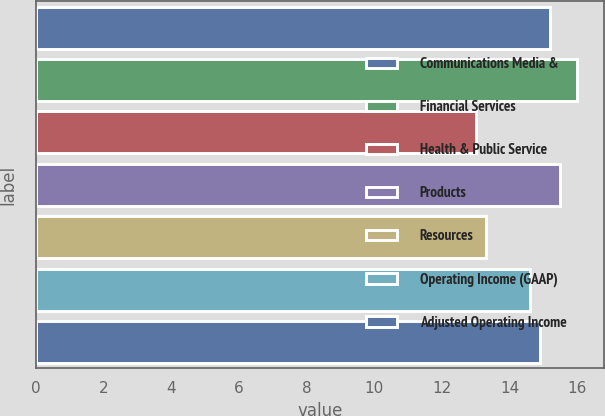<chart> <loc_0><loc_0><loc_500><loc_500><bar_chart><fcel>Communications Media &<fcel>Financial Services<fcel>Health & Public Service<fcel>Products<fcel>Resources<fcel>Operating Income (GAAP)<fcel>Adjusted Operating Income<nl><fcel>15.2<fcel>16<fcel>13<fcel>15.5<fcel>13.3<fcel>14.6<fcel>14.9<nl></chart> 